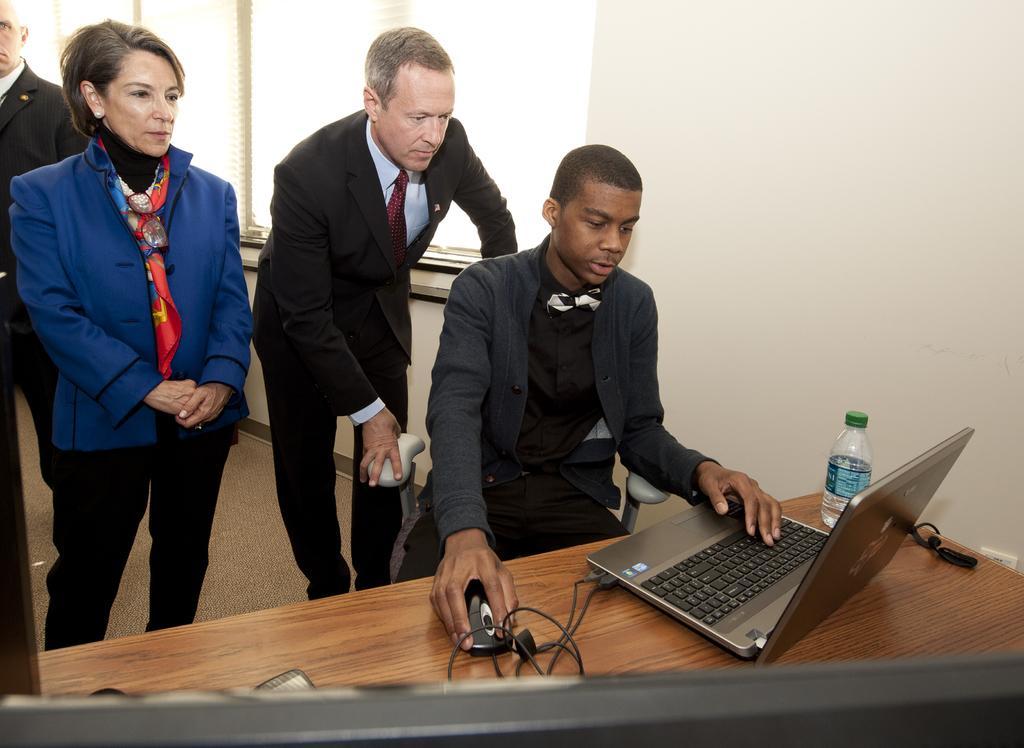Could you give a brief overview of what you see in this image? Here in this picture we can see 4 people and three of them are standing and one guy is sitting on a chair with a laptop in front of him he is using the laptop and there is a bottle beside him 